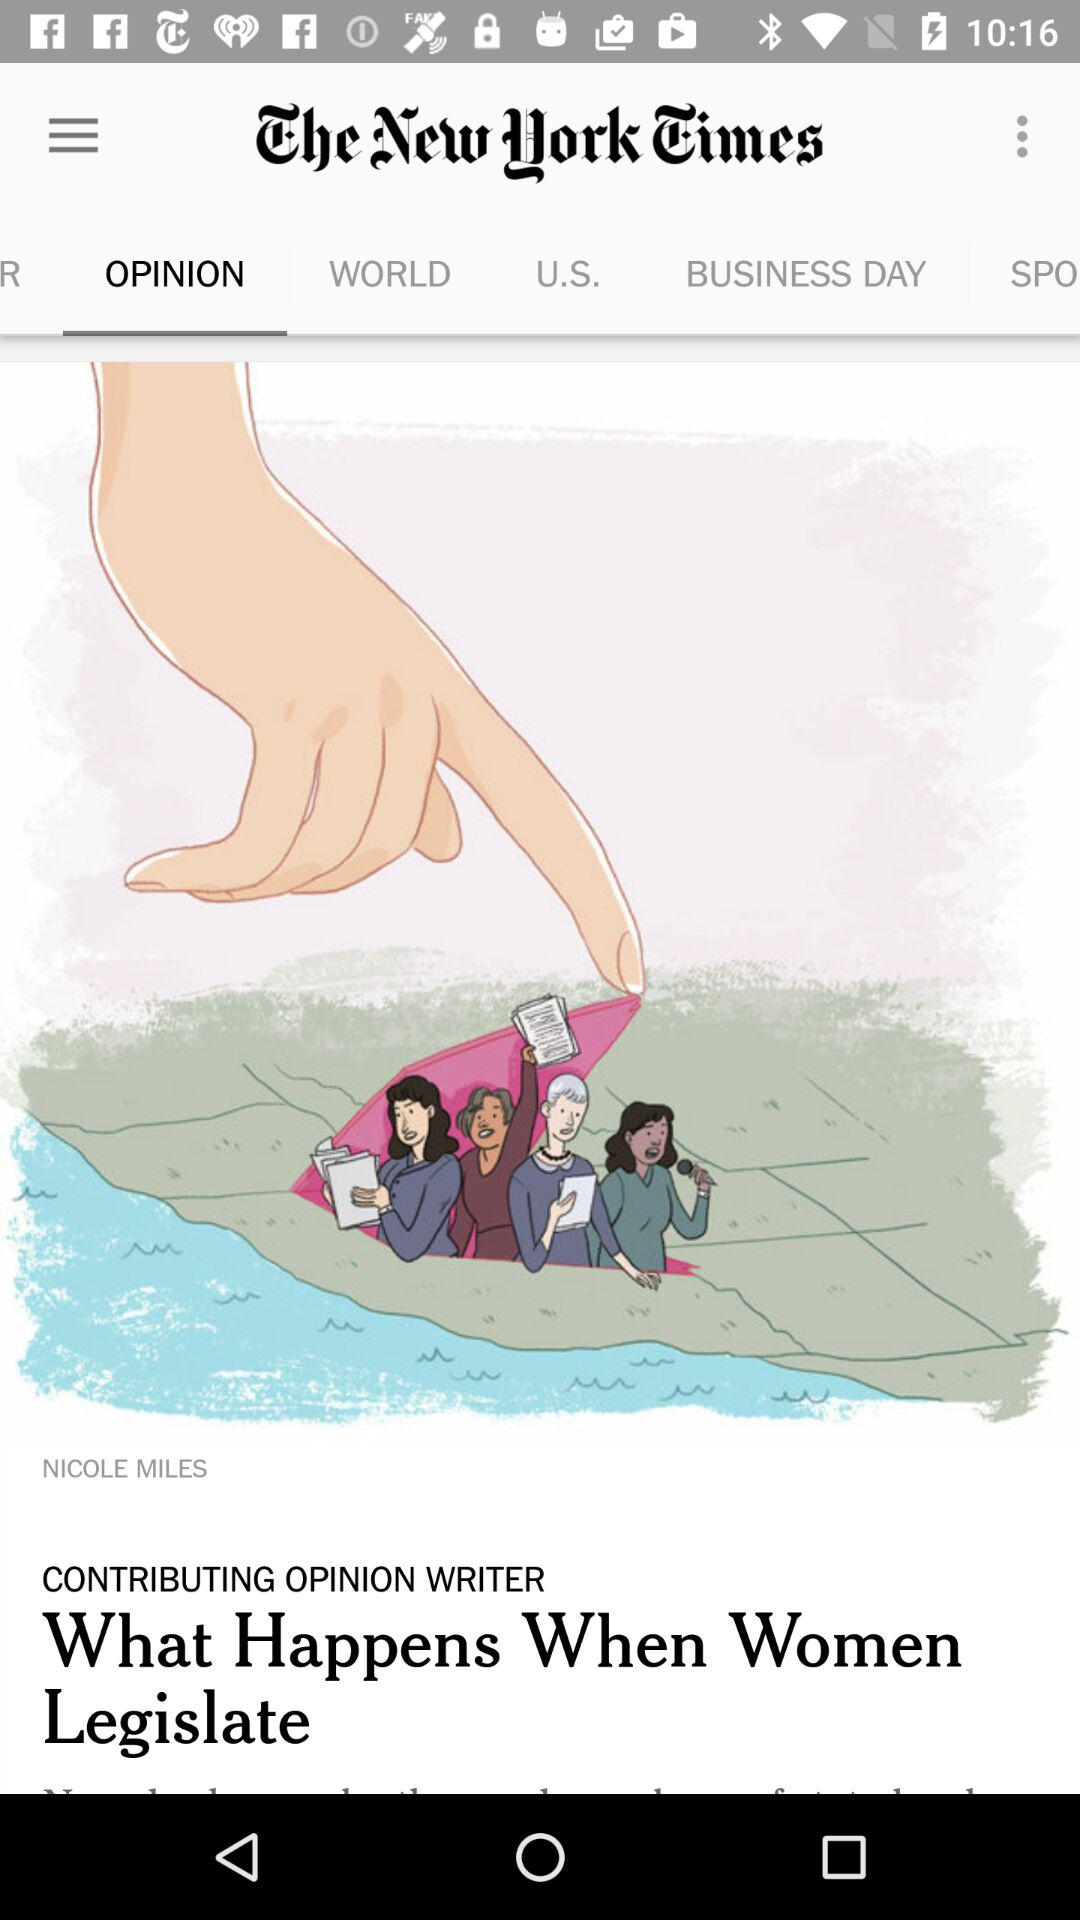Which option is selected? The selected option is "Opinion". 